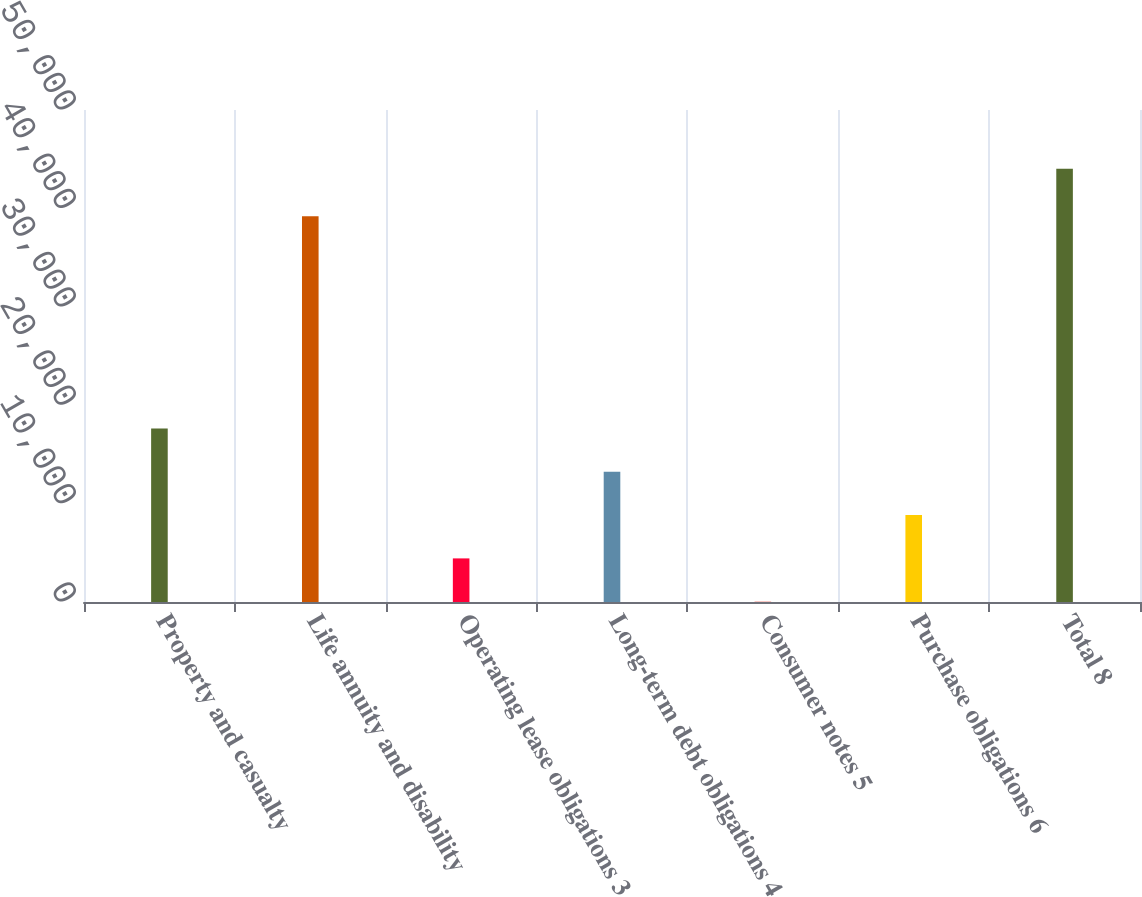Convert chart to OTSL. <chart><loc_0><loc_0><loc_500><loc_500><bar_chart><fcel>Property and casualty<fcel>Life annuity and disability<fcel>Operating lease obligations 3<fcel>Long-term debt obligations 4<fcel>Consumer notes 5<fcel>Purchase obligations 6<fcel>Total 8<nl><fcel>17628<fcel>39194<fcel>4431<fcel>13229<fcel>32<fcel>8830<fcel>44022<nl></chart> 